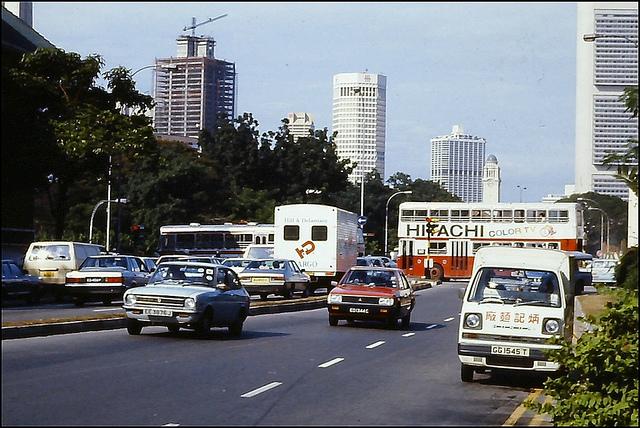Are the cars oldtimers?
Quick response, please. Yes. Are the cars in focus?
Give a very brief answer. Yes. There is one arrow?
Write a very short answer. No. What insignia is on the truck?
Quick response, please. Hitachi. What is advertised on the side of the bus?
Answer briefly. Hitachi. What type of construction equipment on top of the building?
Short answer required. Crane. 